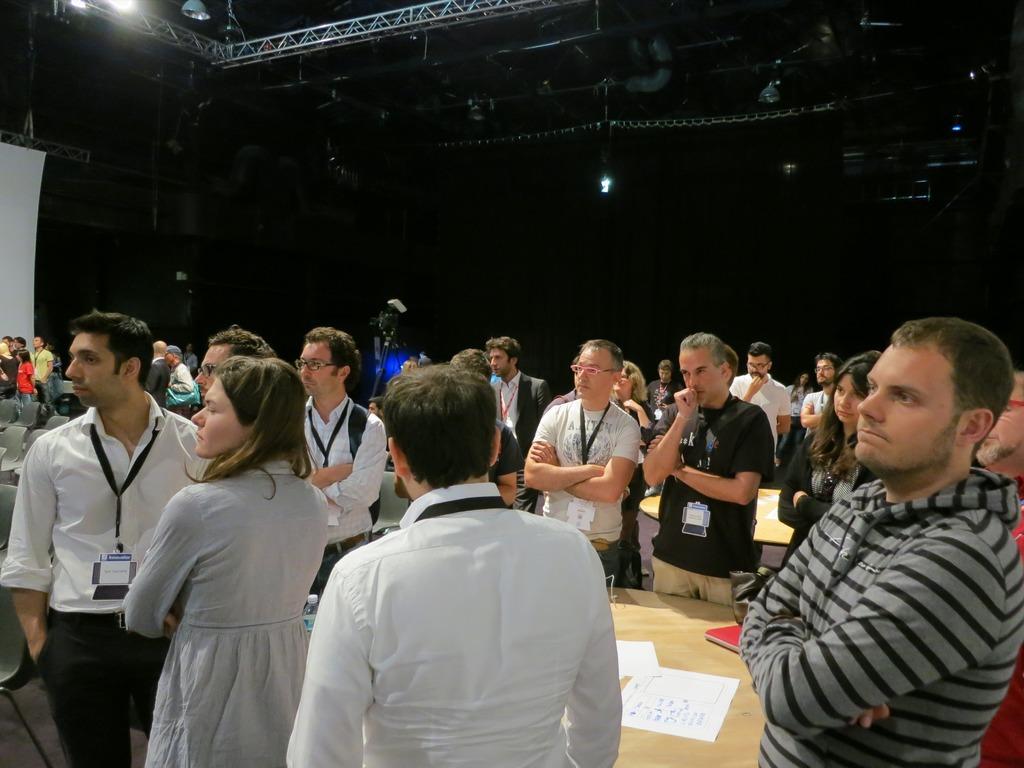Describe this image in one or two sentences. Here in this picture, we can see number of people standing over a place and most of them are wearing ID cards and in the middle we can see tables present on the floor, on which we can see papers and books present and above them we can see an iron frame present and we we can see lights also present. 